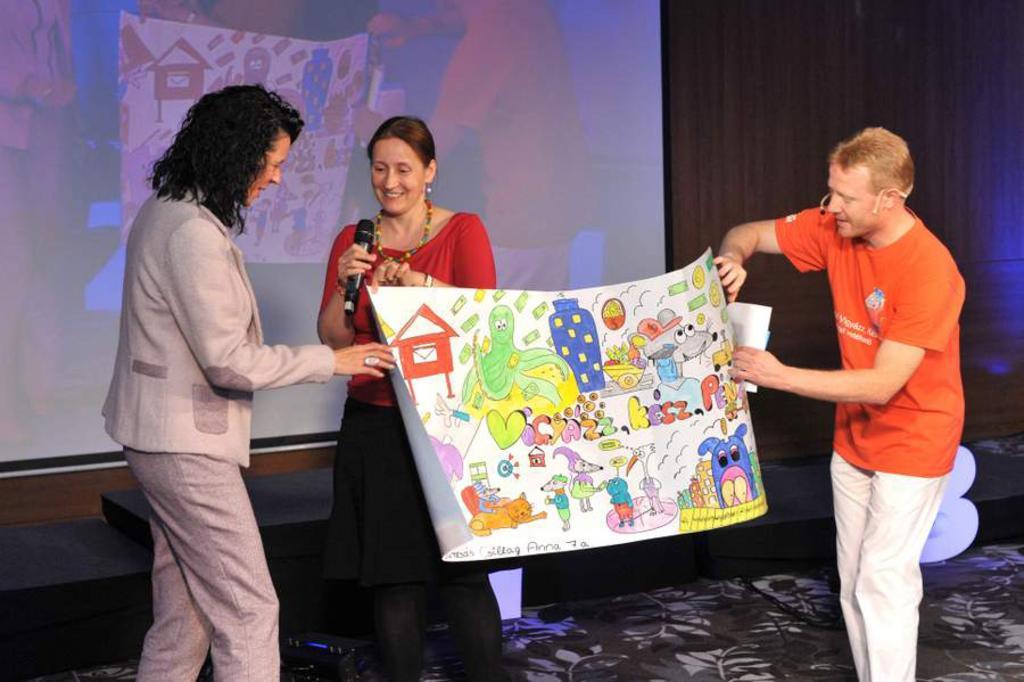Please provide a concise description of this image. In this image there are two persons standing on the stage by holding the chart. In the chart there are drawings. Behind the chart there is a woman who is standing on the stage by holding the mic. In the background there is a screen. Beside the screen there are curtains. 